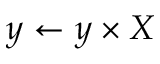<formula> <loc_0><loc_0><loc_500><loc_500>y \gets y \times X</formula> 